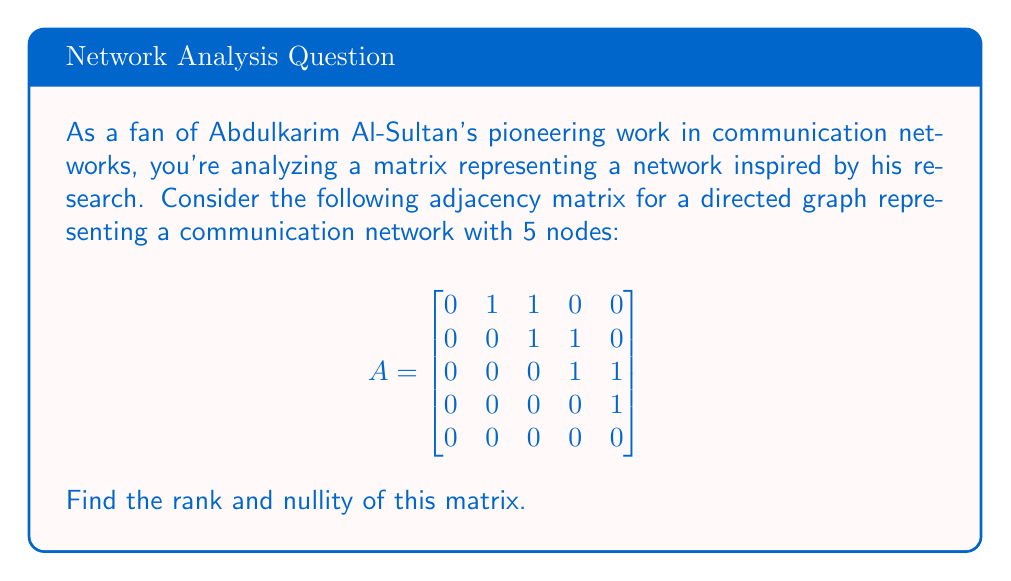Could you help me with this problem? Let's approach this step-by-step:

1) First, we need to find the rank of the matrix. The rank is equal to the number of linearly independent rows or columns.

2) To find the rank, we'll use the Gaussian elimination method to obtain the row echelon form:

   $$\begin{bmatrix}
   0 & 1 & 1 & 0 & 0 \\
   0 & 0 & 1 & 1 & 0 \\
   0 & 0 & 0 & 1 & 1 \\
   0 & 0 & 0 & 0 & 1 \\
   0 & 0 & 0 & 0 & 0
   \end{bmatrix}$$

3) The matrix is already in row echelon form. The rank is equal to the number of non-zero rows.

4) We can see that there are 4 non-zero rows. Therefore, the rank of the matrix is 4.

5) Now, let's find the nullity. The nullity is defined as:
   
   nullity = n - rank

   Where n is the number of columns in the matrix.

6) In this case:
   n = 5 (there are 5 columns)
   rank = 4 (as we found earlier)

   So, nullity = 5 - 4 = 1

Therefore, the rank of the matrix is 4 and the nullity is 1.
Answer: Rank = 4, Nullity = 1 